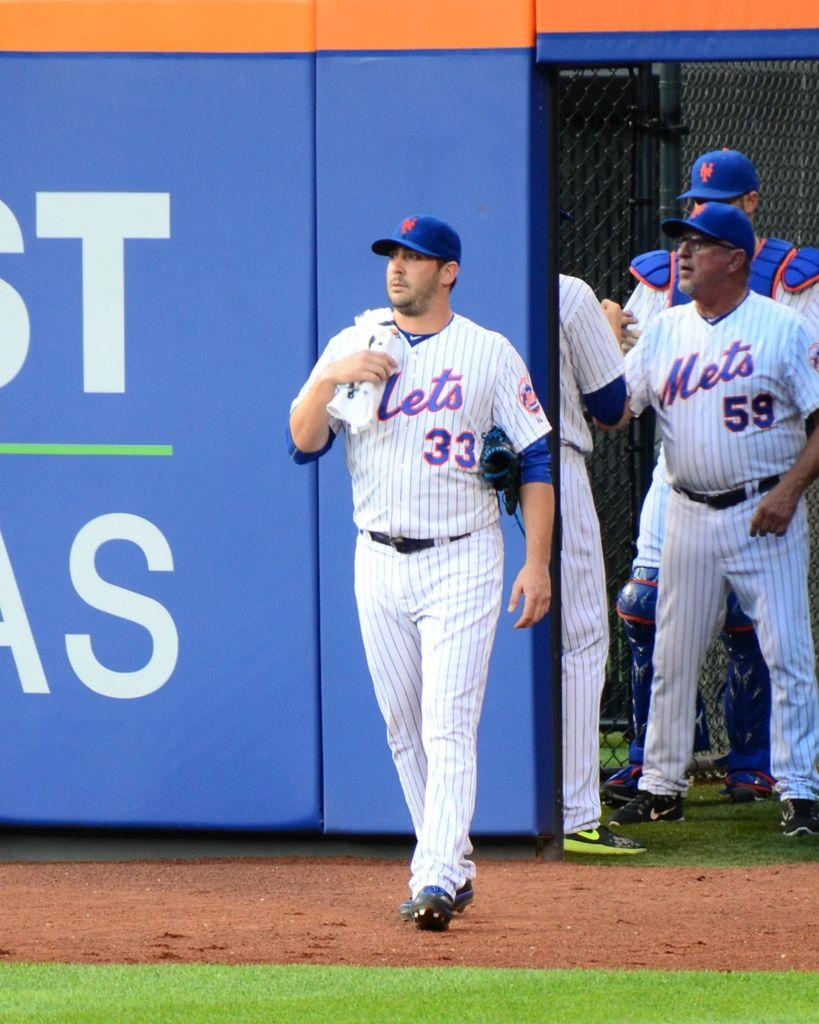<image>
Describe the image concisely. Number 33 of the New York Mets is walking from the bullpen onto the field. 